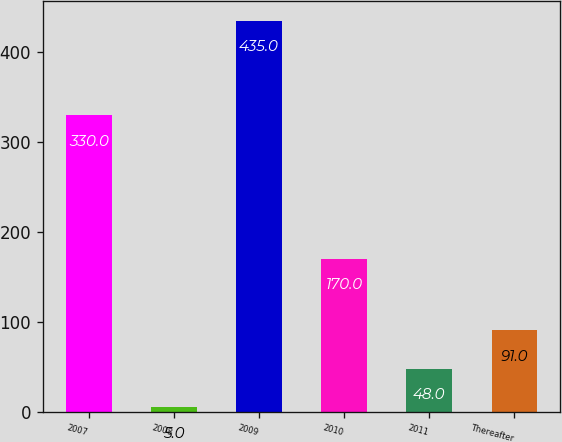Convert chart. <chart><loc_0><loc_0><loc_500><loc_500><bar_chart><fcel>2007<fcel>2008<fcel>2009<fcel>2010<fcel>2011<fcel>Thereafter<nl><fcel>330<fcel>5<fcel>435<fcel>170<fcel>48<fcel>91<nl></chart> 